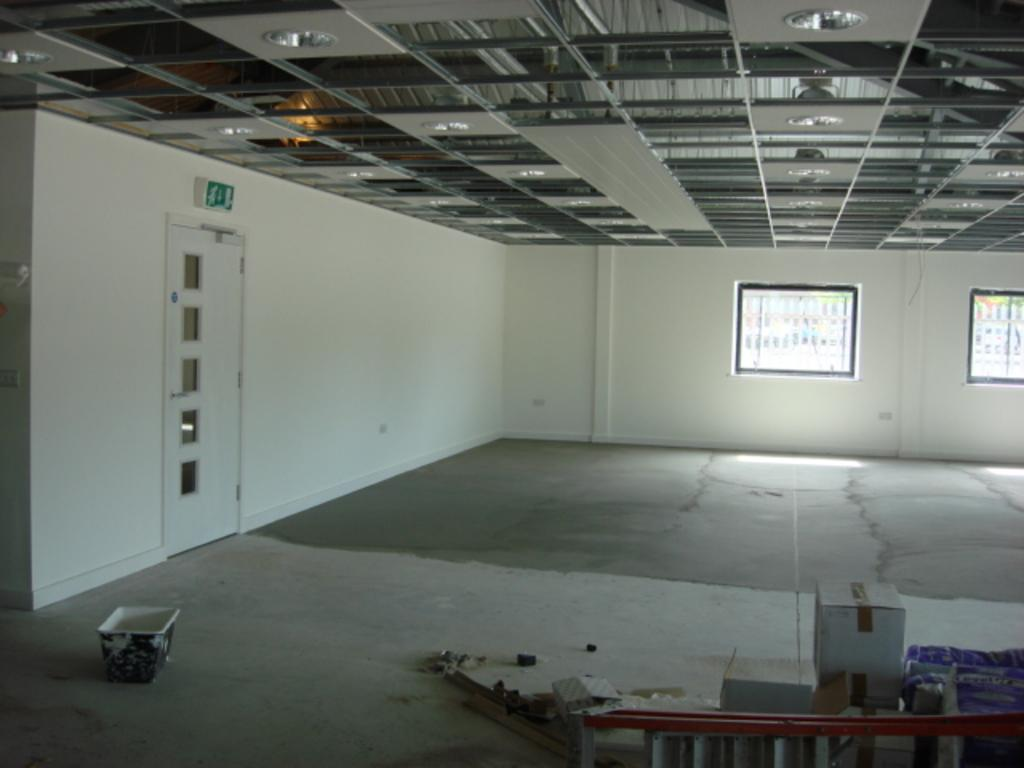What is the main object in the image? There is a tub in the image. What else can be seen in the image besides the tub? There are boxes and objects on the floor in the image. Can you describe the surroundings of the tub? There is a door and walls in the image, and windows are visible in the background. What type of knot is being used to secure the boxes in the image? There is no knot visible in the image; the boxes are not tied or secured in any way. 